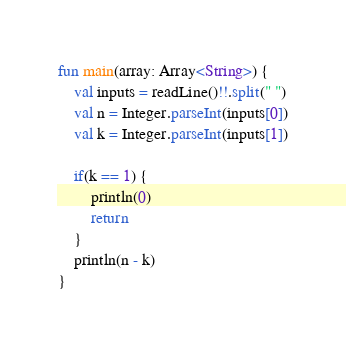Convert code to text. <code><loc_0><loc_0><loc_500><loc_500><_Kotlin_>fun main(array: Array<String>) {
	val inputs = readLine()!!.split(" ")
	val n = Integer.parseInt(inputs[0])
	val k = Integer.parseInt(inputs[1])

	if(k == 1) {
		println(0)
		return
	}
	println(n - k)
}
</code> 